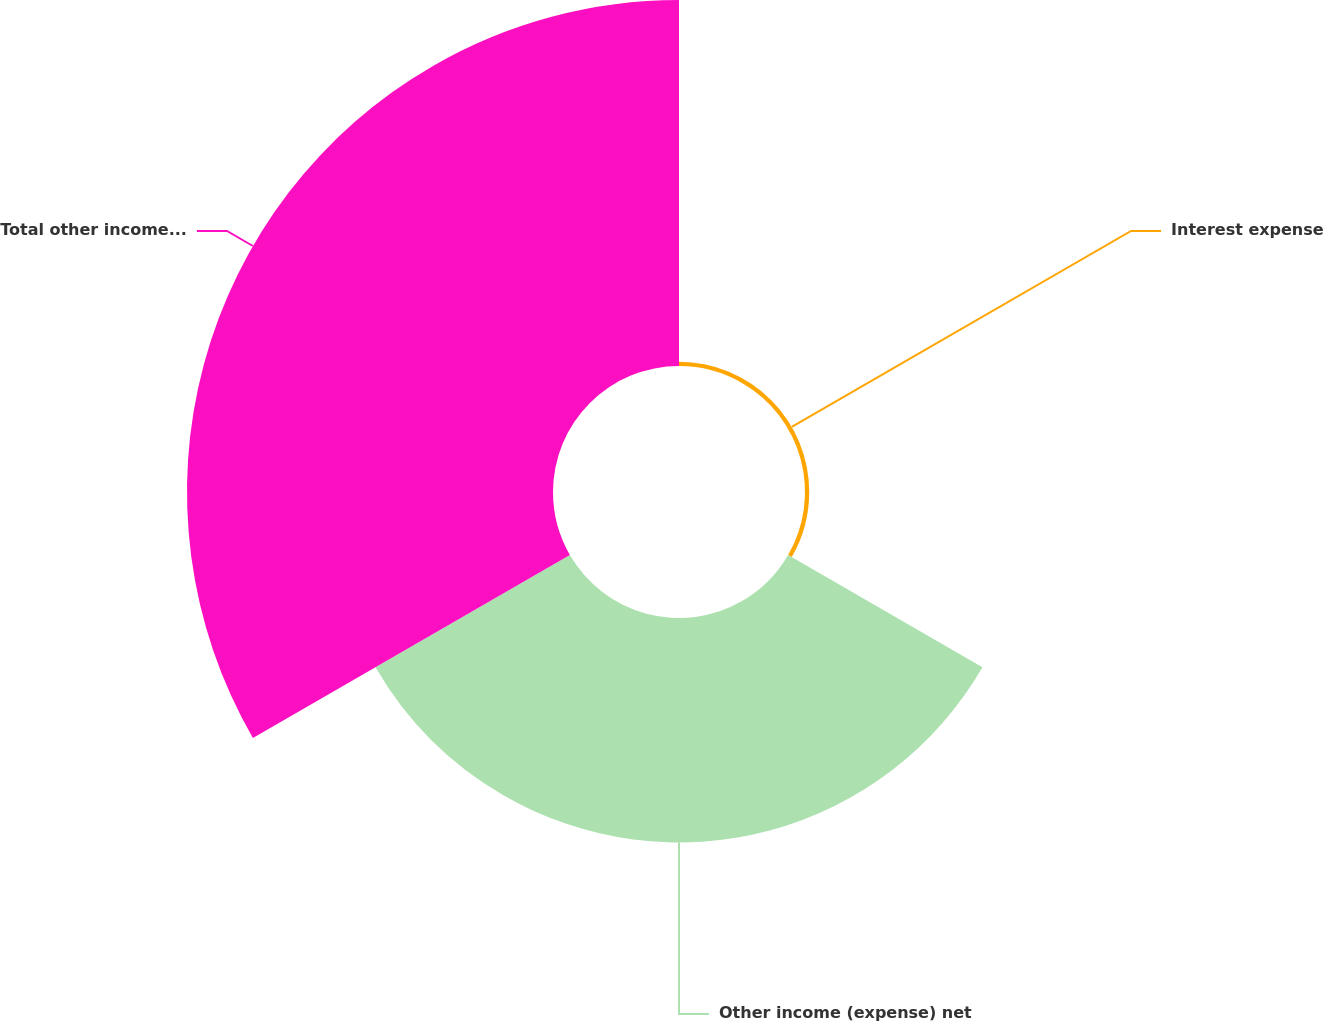<chart> <loc_0><loc_0><loc_500><loc_500><pie_chart><fcel>Interest expense<fcel>Other income (expense) net<fcel>Total other income (expense)<nl><fcel>0.71%<fcel>37.74%<fcel>61.55%<nl></chart> 